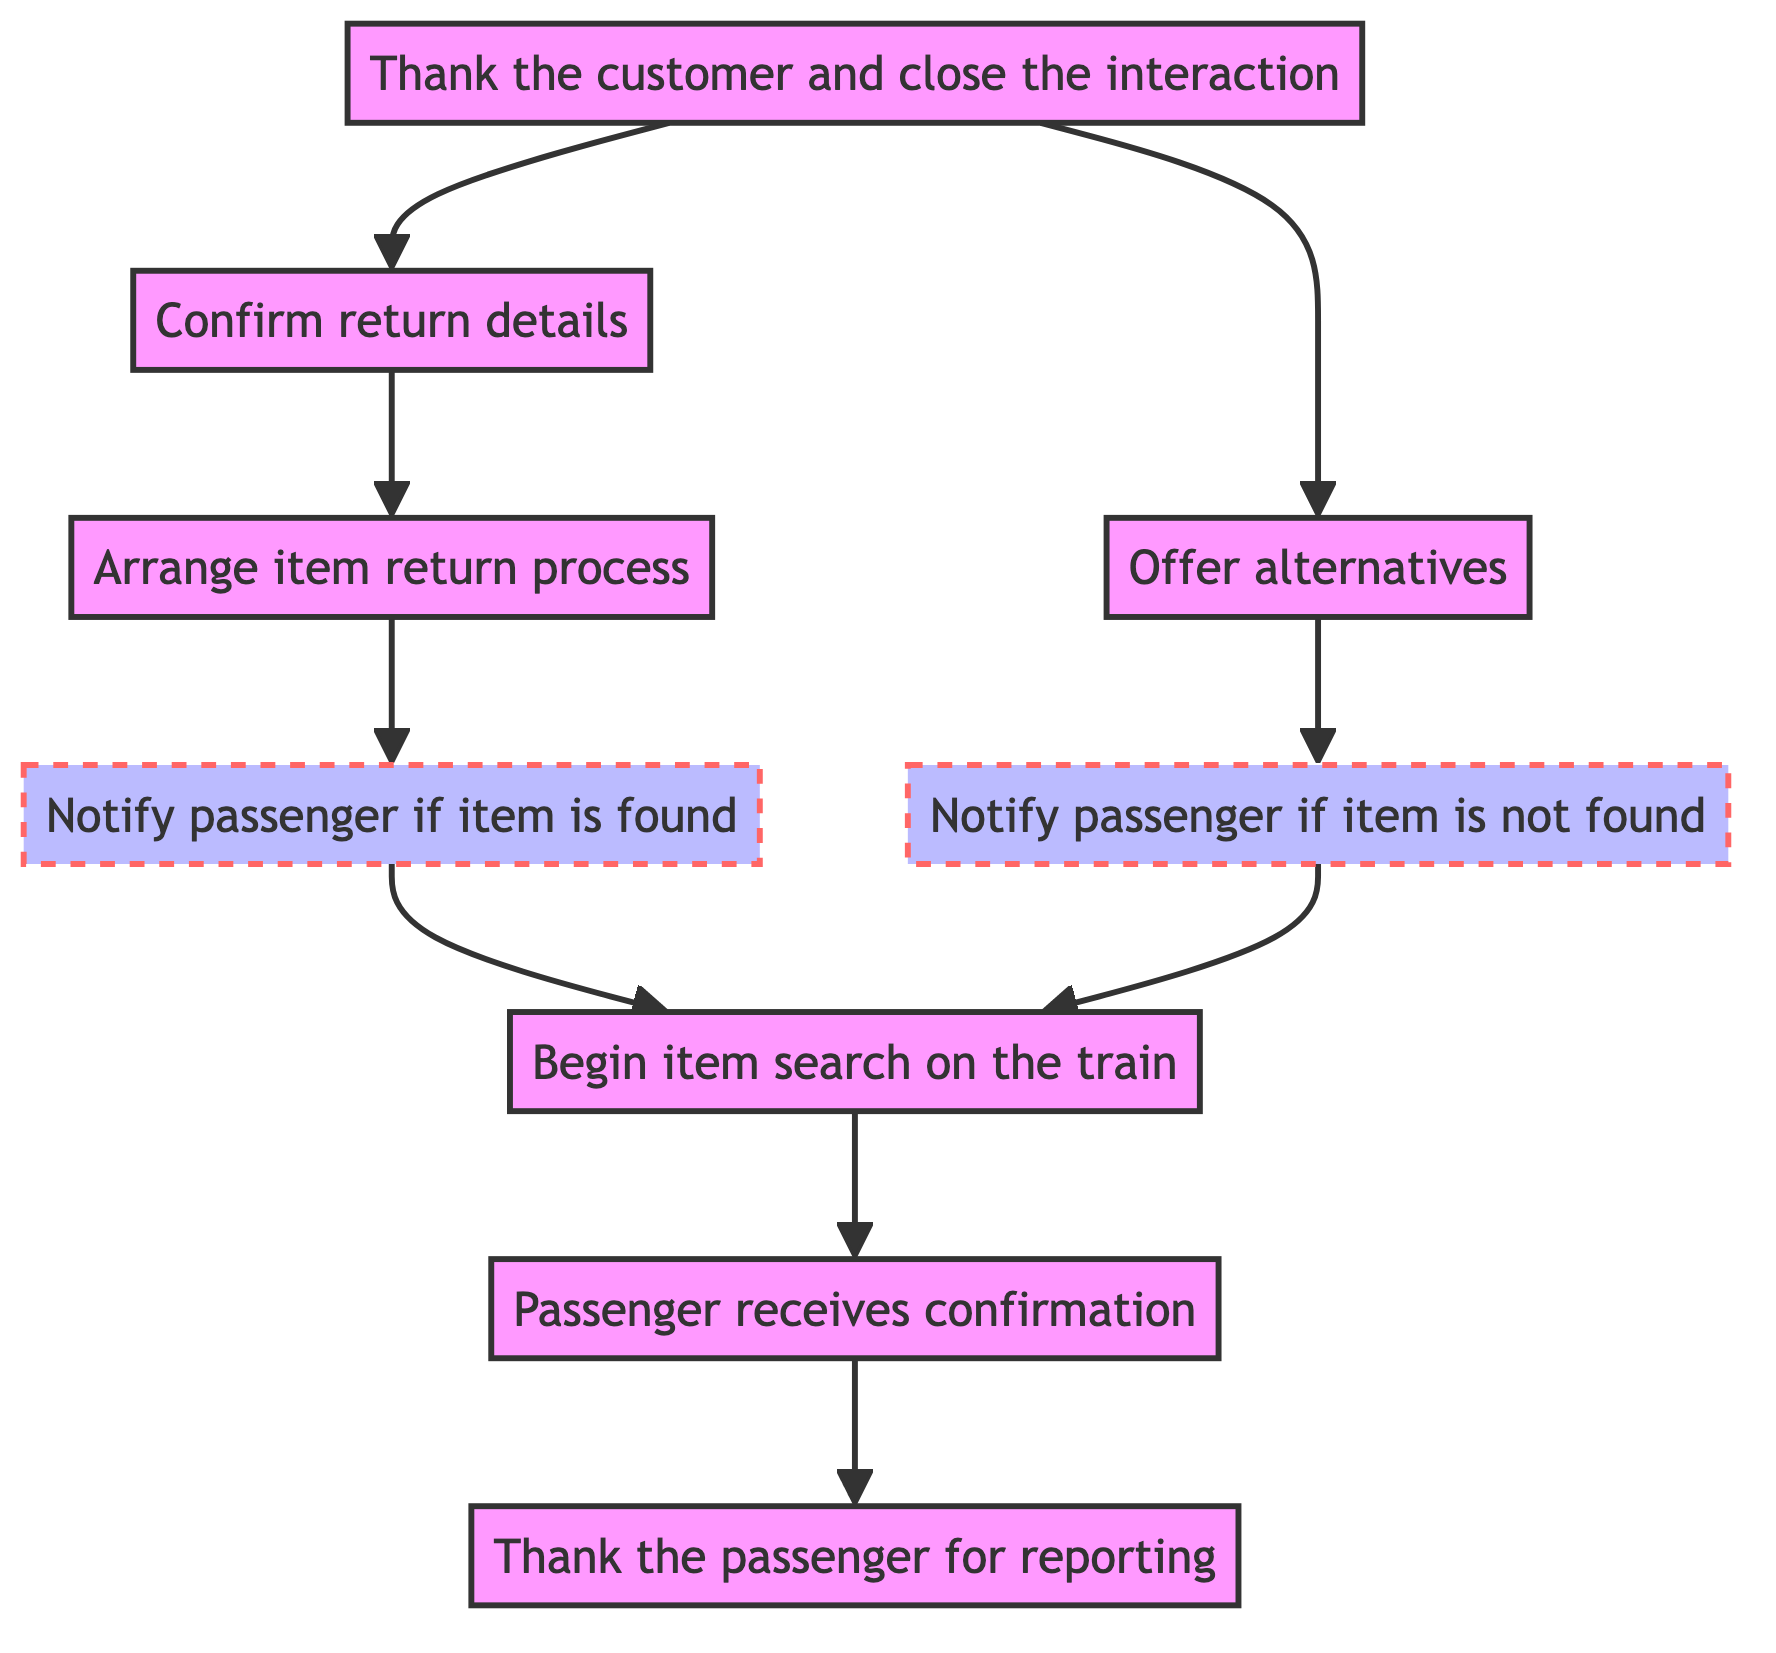What is the first step after a passenger reports a lost item? The first step is to thank the passenger for reporting, as indicated by the flow starting from the bottom of the diagram.
Answer: Thank the passenger for reporting How many main actions follow the receipt of confirmation by the passenger? After the passenger receives confirmation, there are two main actions: either notify found item or notify unfound item.
Answer: Two What happens if the item is found? If the item is found, the flow indicates that the passenger will be notified that their lost item has been identified and the location for retrieval will be stated.
Answer: Notify passenger if item is found What action follows confirming return details? The action that follows confirming return details is to thank the customer and close the interaction, which represents the conclusion of the process.
Answer: Thank the customer and close the interaction What are the two possible outcomes after the search begins? The two possible outcomes after beginning the item search are notifying the passenger if the item is found or notifying them if the item is not found.
Answer: Notify passenger if item is found or notify passenger if item is not found What node describes an appreciation gesture towards the passenger? The node that describes an appreciation gesture towards the passenger is the one labeled “Thank the passenger for reporting.”
Answer: Thank the passenger for reporting Can the passenger receive alternative solutions if the item is not found? Yes, the diagram indicates that if the item is not found, passengers can be offered alternatives which may include solutions or advice.
Answer: Offer alternatives Which node serves as a confirmation step in the item recovery process? The node that serves as a confirmation step in the item recovery process is “Confirm return details,” ensuring that all the return specifics are verified.
Answer: Confirm return details What must happen before the item return process can be arranged? Before the item return process can be arranged, it is necessary to notify the passenger that their item has been found, signaling the start of the return process.
Answer: Notify passenger if item is found 